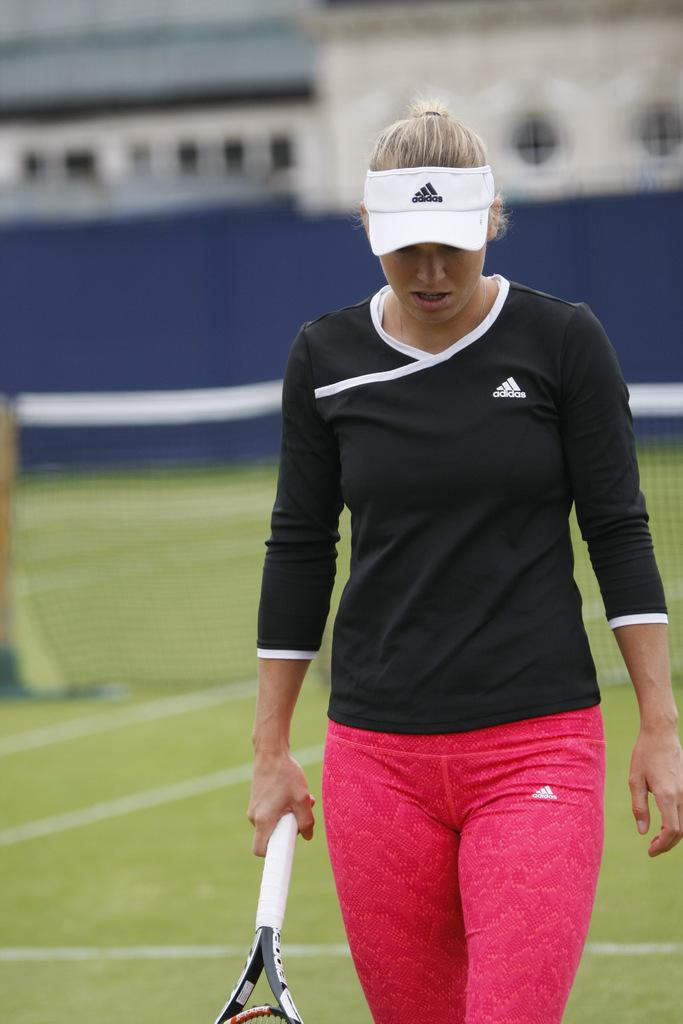Who is present in the image? There is a woman in the image. What is the woman doing in the image? The woman is standing and holding a tennis racket. What can be seen behind the woman? There is a net behind the woman. What is visible at the top of the image? There is fencing at the top of the image. What type of reaction does the bee have when it sees the woman in the image? There is no bee present in the image, so it is not possible to determine its reaction. 